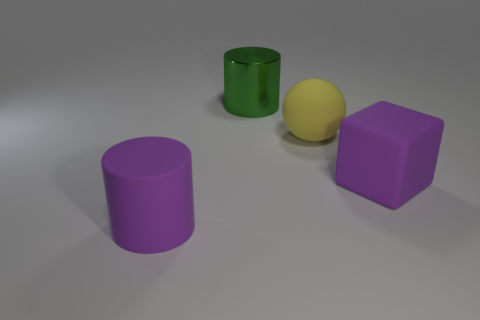What size is the matte thing on the right side of the yellow thing?
Keep it short and to the point. Large. What number of green cylinders have the same size as the ball?
Your answer should be very brief. 1. What size is the cylinder that is the same color as the cube?
Offer a terse response. Large. Is there a cylinder of the same color as the block?
Your response must be concise. Yes. The other shiny object that is the same size as the yellow object is what color?
Offer a very short reply. Green. Does the cube have the same color as the large cylinder that is in front of the large yellow thing?
Offer a terse response. Yes. What color is the big sphere?
Provide a short and direct response. Yellow. There is a object on the right side of the big yellow thing; what is its material?
Provide a short and direct response. Rubber. Are there fewer rubber spheres that are right of the sphere than big yellow rubber spheres?
Keep it short and to the point. Yes. Are any big purple metallic spheres visible?
Provide a succinct answer. No. 